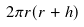<formula> <loc_0><loc_0><loc_500><loc_500>2 \pi r ( r + h ) \,</formula> 